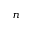<formula> <loc_0><loc_0><loc_500><loc_500>n</formula> 